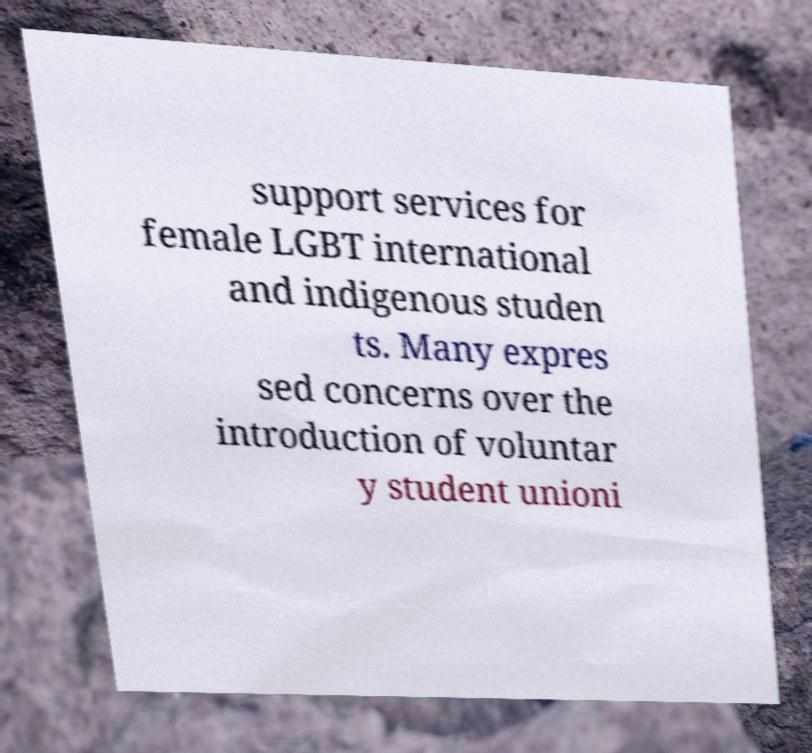There's text embedded in this image that I need extracted. Can you transcribe it verbatim? support services for female LGBT international and indigenous studen ts. Many expres sed concerns over the introduction of voluntar y student unioni 